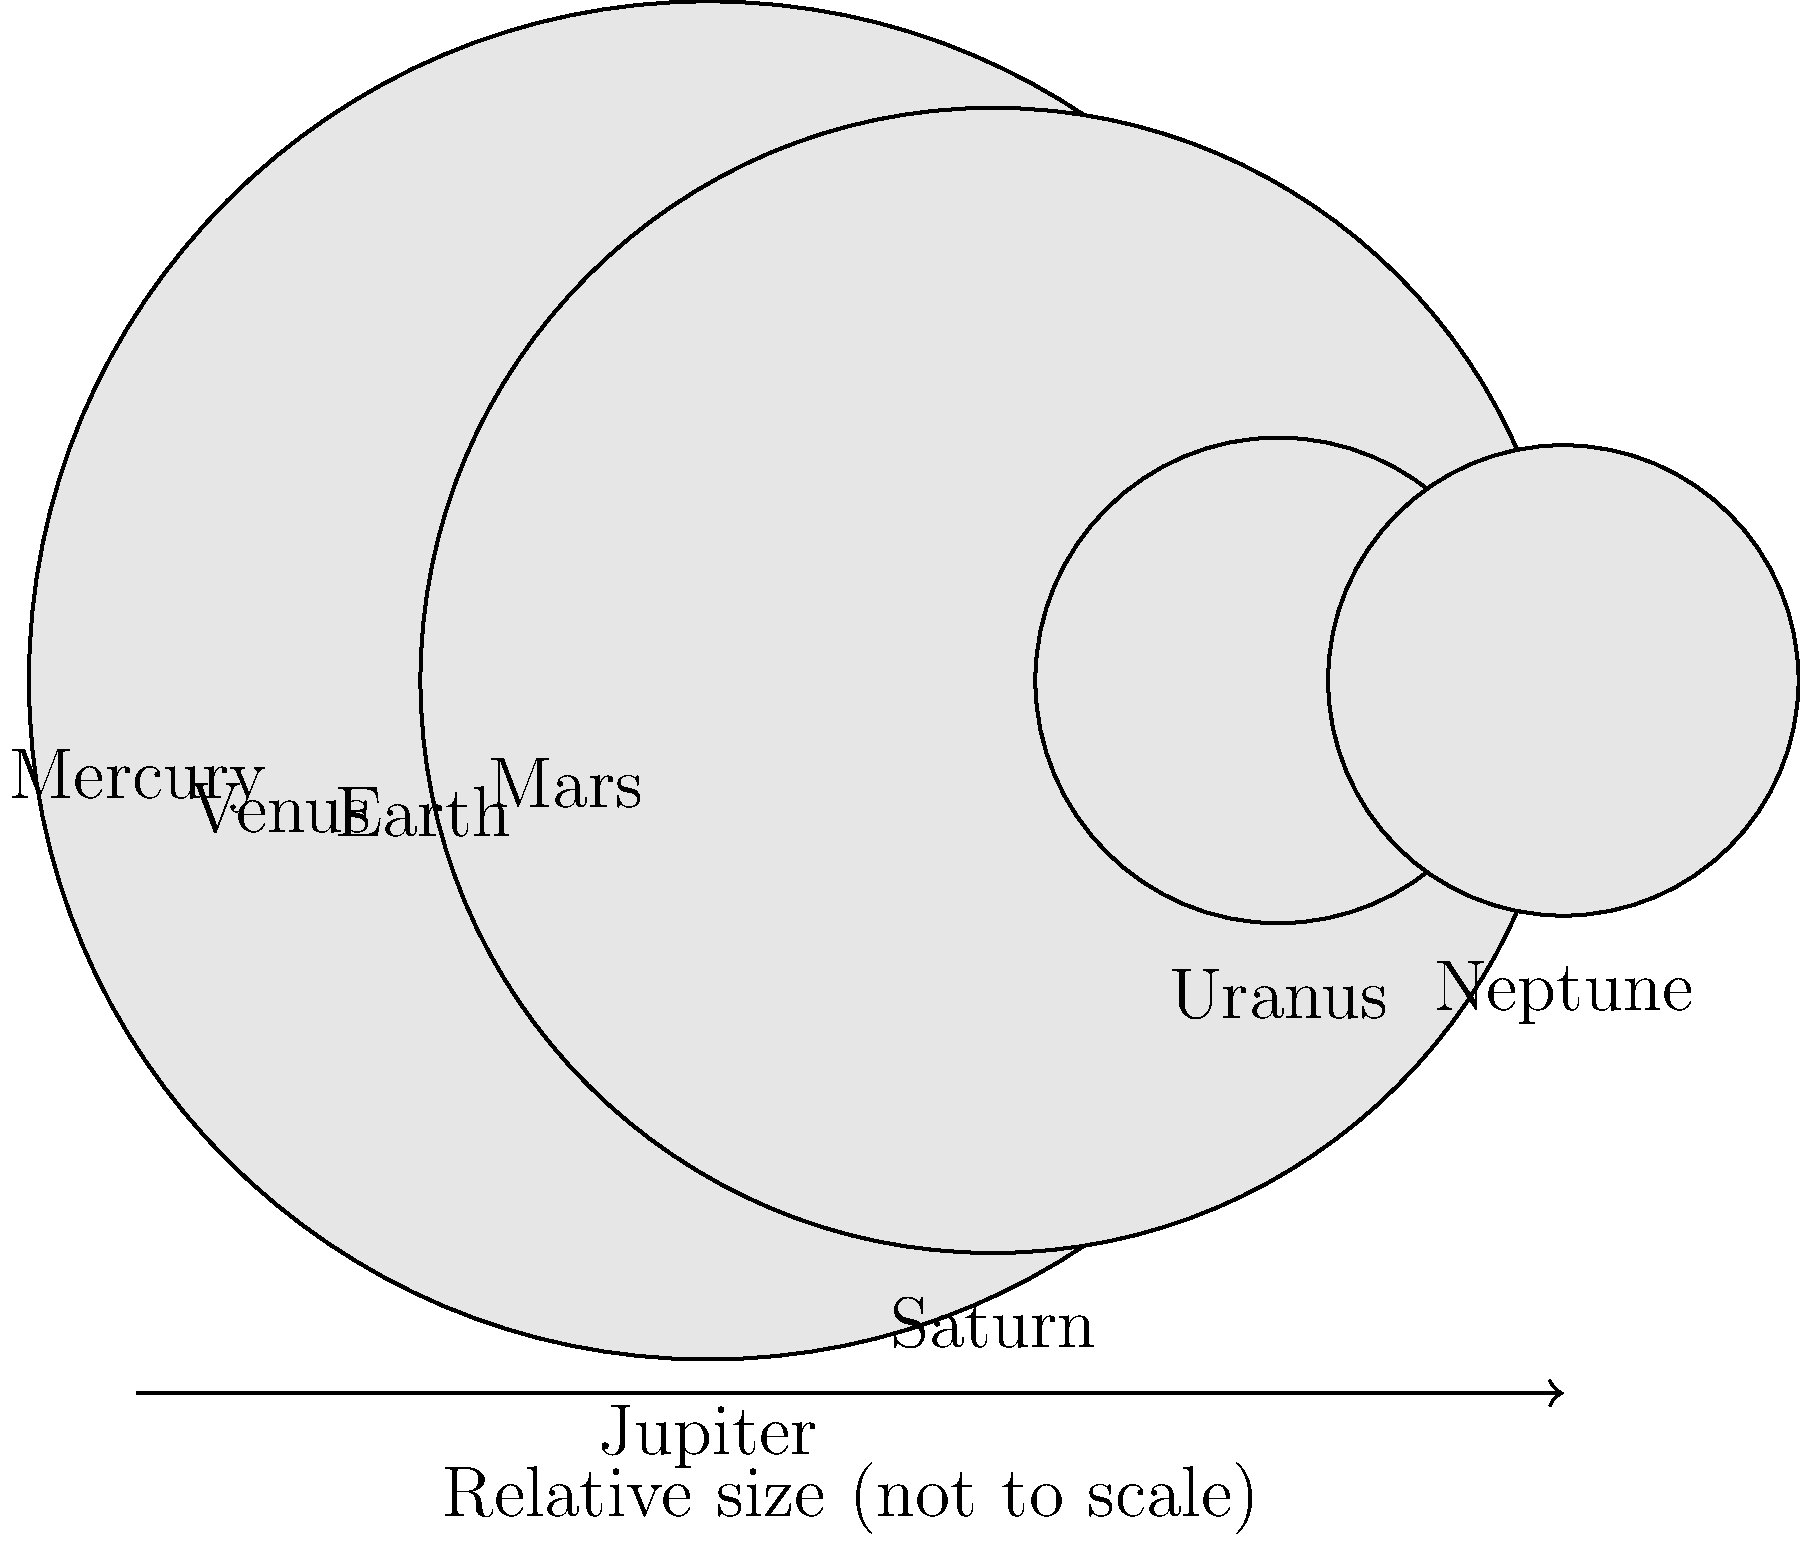As a web developer familiar with Polymer's data binding and scaling techniques, how would you approach creating a responsive visualization of the planets' relative sizes? Which planet's radius is approximately 11.2 times larger than Earth's in this scaled representation? To solve this problem, let's follow these steps:

1. Understand the data:
   The radii given in the image represent the relative sizes of the planets.

2. Identify Earth's radius:
   Earth's radius is given as 12.8 units in this scaled representation.

3. Calculate the ratio for each planet compared to Earth:
   For each planet, divide its radius by Earth's radius (12.8).

4. Find the planet with a ratio close to 11.2:
   Jupiter: 142.9 / 12.8 ≈ 11.16
   Saturn: 120.5 / 12.8 ≈ 9.41
   Uranus: 51.1 / 12.8 ≈ 3.99
   Neptune: 49.5 / 12.8 ≈ 3.87
   (Smaller planets have even lower ratios)

5. Identify the closest match:
   Jupiter's ratio (11.16) is the closest to 11.2.

From a web development perspective, to create a responsive visualization:
1. Use Polymer's data binding to dynamically set the sizes of planet elements.
2. Implement a scaling function that adjusts planet sizes based on screen dimensions.
3. Utilize Polymer's iron-resizable-behavior for handling resize events efficiently.
4. Consider using SVG for smooth scaling of the circular planet representations.
Answer: Jupiter 